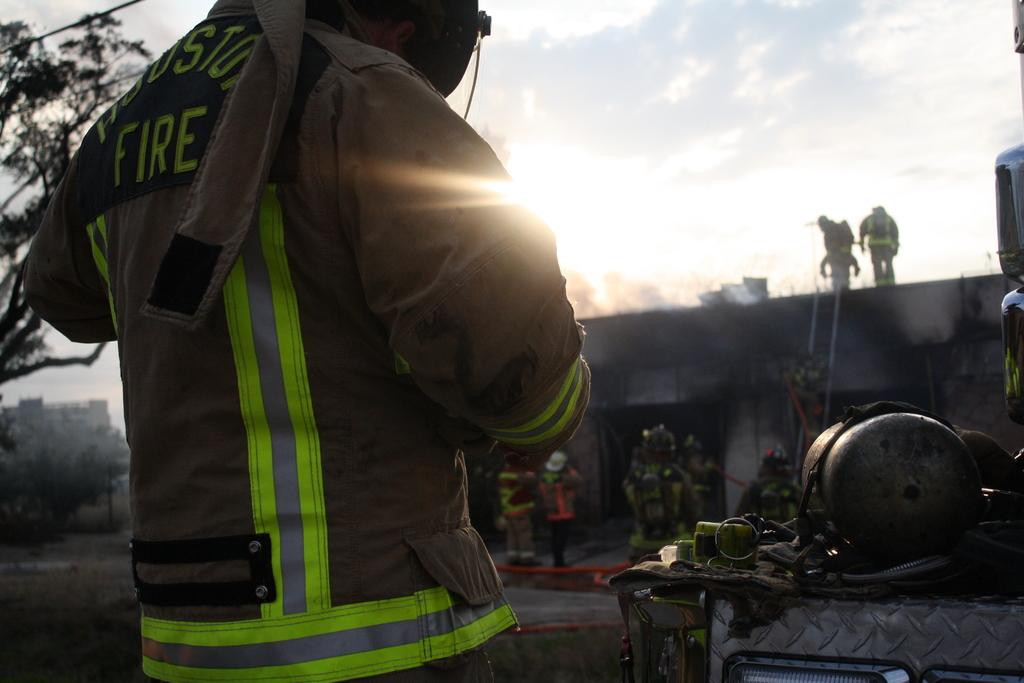What is the main subject of the image? There is a person standing in the image. What can be seen on the right side of the image? There are objects on the right side of the image. What is visible in the background of the image? The background of the image includes houses, trees, a building, people, a ladder, pipes, and the sky. What type of mist can be seen surrounding the person in the image? There is no mist present in the image; the person is standing in a clear environment. Is there a gun visible in the image? No, there is no gun present in the image. 